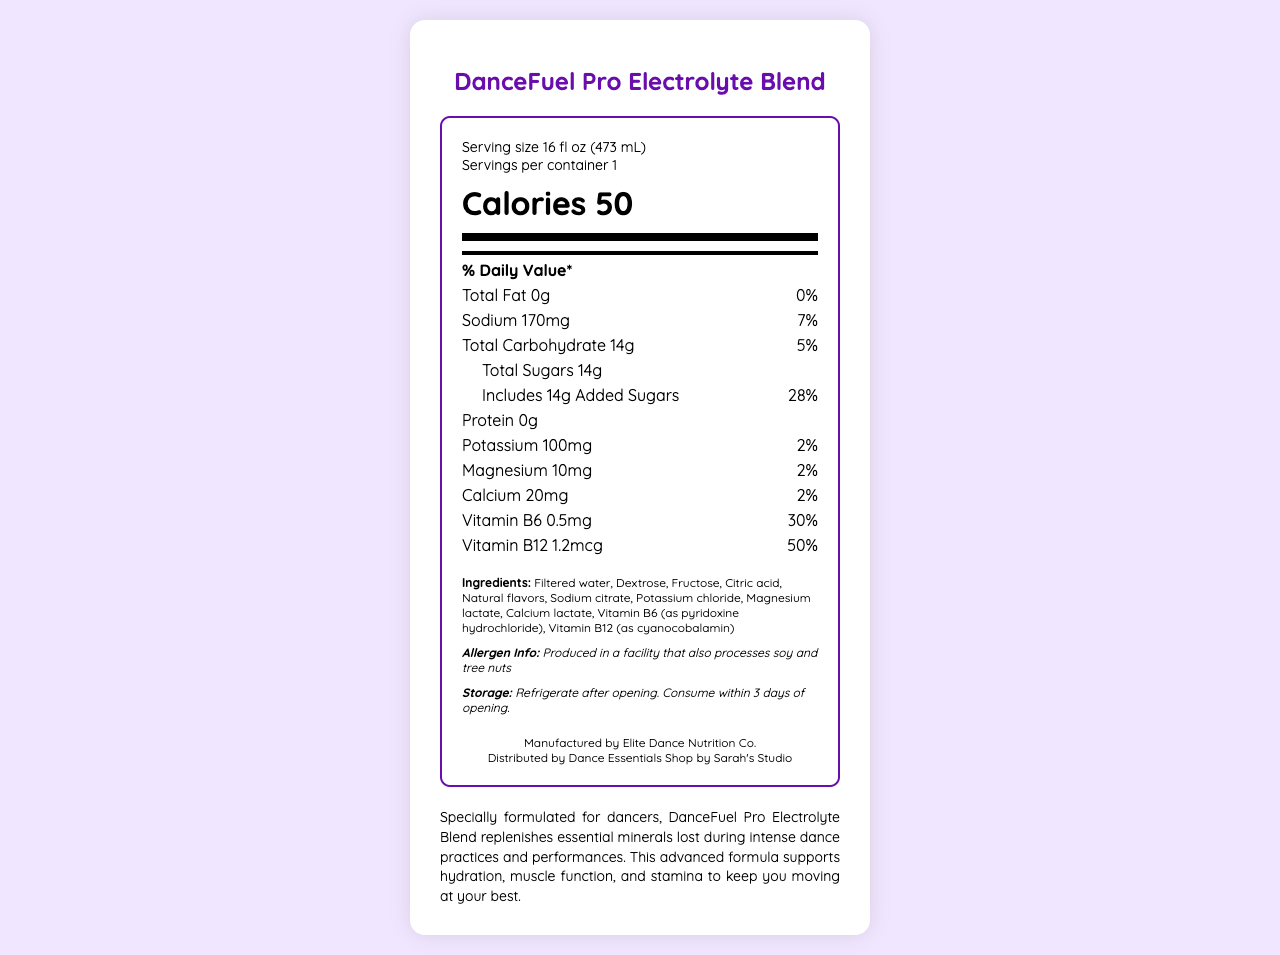what is the serving size of DanceFuel Pro Electrolyte Blend? The serving size is explicitly mentioned in the "serving size" section of the label as 16 fl oz (473 mL).
Answer: 16 fl oz (473 mL) how many calories are in one serving? The number of calories per serving is clearly listed as 50 in the label.
Answer: 50 list three minerals found in this drink and their amounts These minerals and their amounts are listed in the nutrient section of the label.
Answer: Sodium: 170mg, Potassium: 100mg, Magnesium: 10mg how much added sugar does this drink contain? The label specifies that the drink includes 14g of added sugars.
Answer: 14g what are the recommended storage instructions for this product? The storage instructions are explicitly stated in the storage section of the label.
Answer: Refrigerate after opening. Consume within 3 days of opening. is this product suitable for someone with a soy allergy? The allergen info states that the product is produced in a facility that also processes soy and tree nuts.
Answer: No which vitamin has the highest daily value percentage in this drink? A. Vitamin B6 B. Vitamin B12 C. Vitamin C Vitamin B12 has a daily value percentage of 50%, which is higher than Vitamin B6's 30%. Vitamin C is not listed in this drink's ingredients.
Answer: B. Vitamin B12 how many servings are there in one container? A. 1 B. 2 C. 3 D. 4 The label clearly states that there is 1 serving per container.
Answer: A. 1 does DanceFuel Pro Electrolyte Blend contain any fat? According to the label, the total fat amount is 0g, indicating there is no fat in the drink.
Answer: No summarize the main purpose of DanceFuel Pro Electrolyte Blend. The product description explains that this electrolyte blend is specially formulated for dancers to help replenish essential minerals lost during intense activities.
Answer: The main purpose of DanceFuel Pro Electrolyte Blend is to replenish essential minerals and support hydration, muscle function, and stamina during intense dance practices and performances. what is the source of vitamin B6 in this drink? The ingredients list states that vitamin B6 is from pyridoxine hydrochloride.
Answer: Pyridoxine hydrochloride what is the name of the manufacturer of this product? The manufacturer is specified as Elite Dance Nutrition Co. in the label.
Answer: Elite Dance Nutrition Co. how many grams of protein does this drink have? According to the label, the protein content is 0g.
Answer: 0g what is the daily value percentage of calcium in this product? The label states that the daily value percentage for calcium is 2%.
Answer: 2% if I drink two servings, how much sodium will I consume? Each serving contains 170mg of sodium. Drinking two servings would double that amount, resulting in 340mg of sodium.
Answer: 340mg how long can you keep this drink once opened? The storage instructions advise consuming the drink within 3 days of opening.
Answer: 3 days who distributes this product? The label mentions that the distributor is Dance Essentials Shop by Sarah's Studio.
Answer: Dance Essentials Shop by Sarah's Studio what is the total amount of potassium and magnesium in one serving? The label lists 100mg of potassium and 10mg of magnesium, which sums up to a total of 110mg.
Answer: 110mg what are the natural flavors in this drink? The label lists "Natural flavors" among the ingredients but does not specify what they are.
Answer: Not enough information 